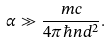<formula> <loc_0><loc_0><loc_500><loc_500>\alpha \gg \frac { m c } { 4 \pi \hbar { n } d ^ { 2 } } .</formula> 